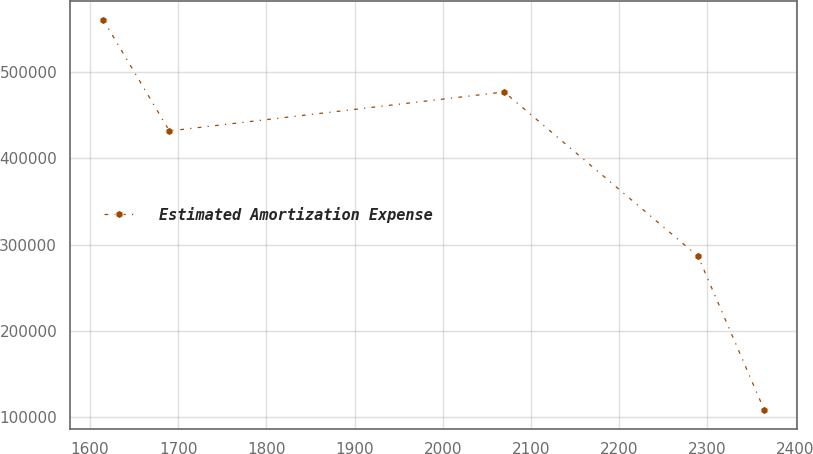<chart> <loc_0><loc_0><loc_500><loc_500><line_chart><ecel><fcel>Estimated Amortization Expense<nl><fcel>1615.15<fcel>560261<nl><fcel>1689.99<fcel>431855<nl><fcel>2069.58<fcel>476961<nl><fcel>2289.49<fcel>286649<nl><fcel>2364.33<fcel>109202<nl></chart> 